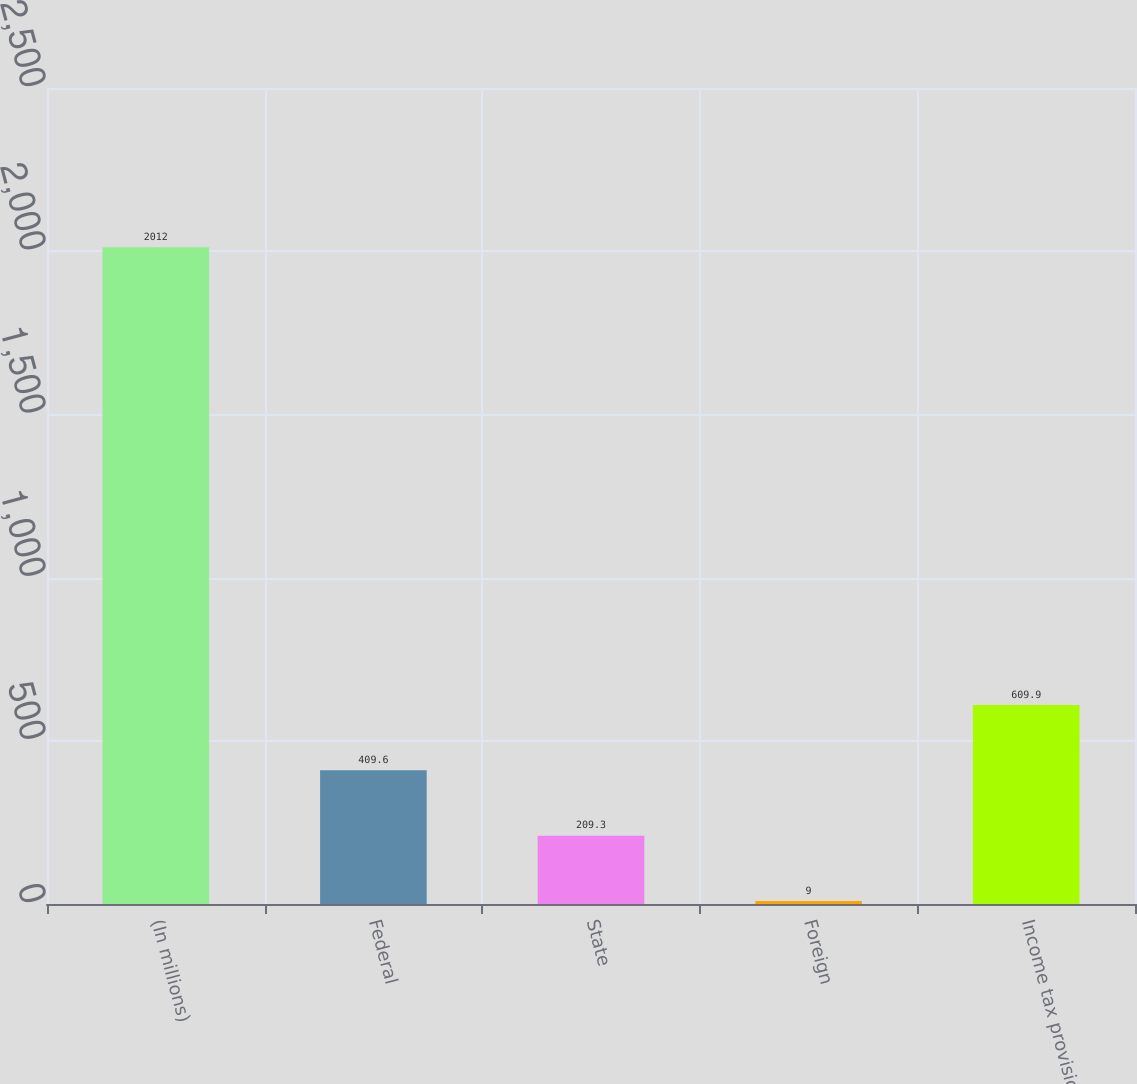Convert chart. <chart><loc_0><loc_0><loc_500><loc_500><bar_chart><fcel>(In millions)<fcel>Federal<fcel>State<fcel>Foreign<fcel>Income tax provision<nl><fcel>2012<fcel>409.6<fcel>209.3<fcel>9<fcel>609.9<nl></chart> 